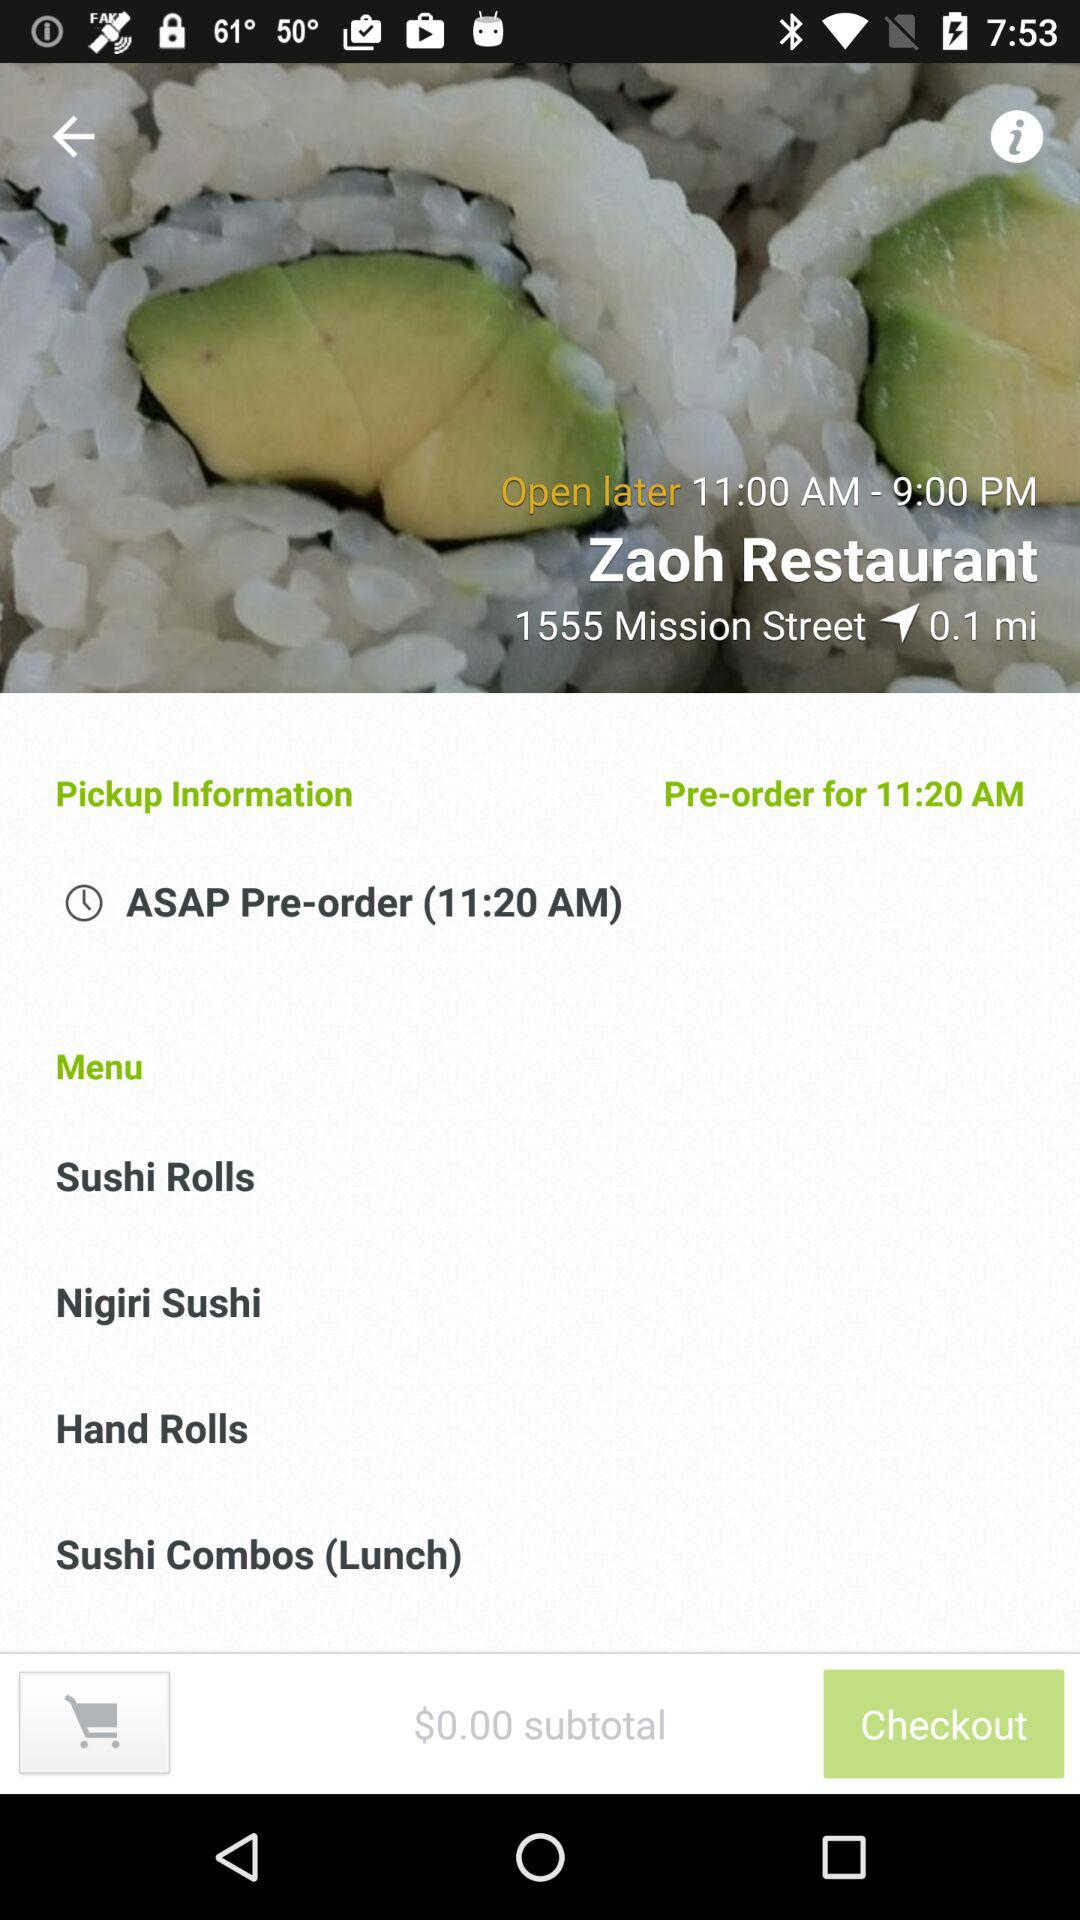What is the pre-order time? The pre-order time is 11:20 AM. 